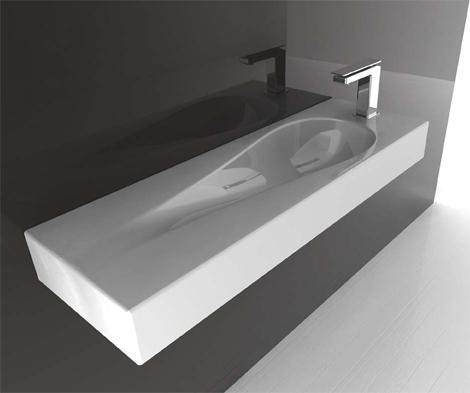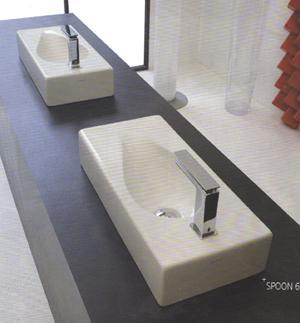The first image is the image on the left, the second image is the image on the right. Assess this claim about the two images: "In one image, two rectangular sinks with chrome faucet fixture are positioned side by side.". Correct or not? Answer yes or no. Yes. The first image is the image on the left, the second image is the image on the right. Analyze the images presented: Is the assertion "The right image features two tear-drop carved white sinks positioned side-by-side." valid? Answer yes or no. Yes. 